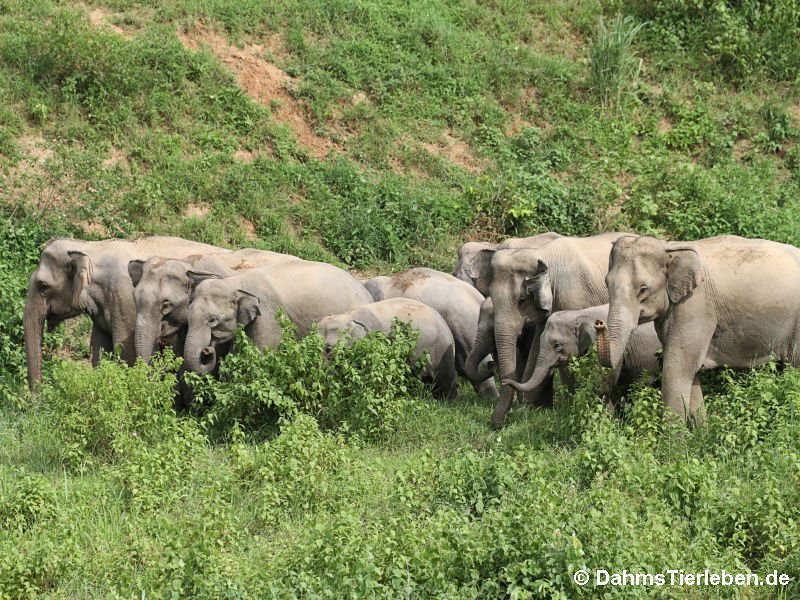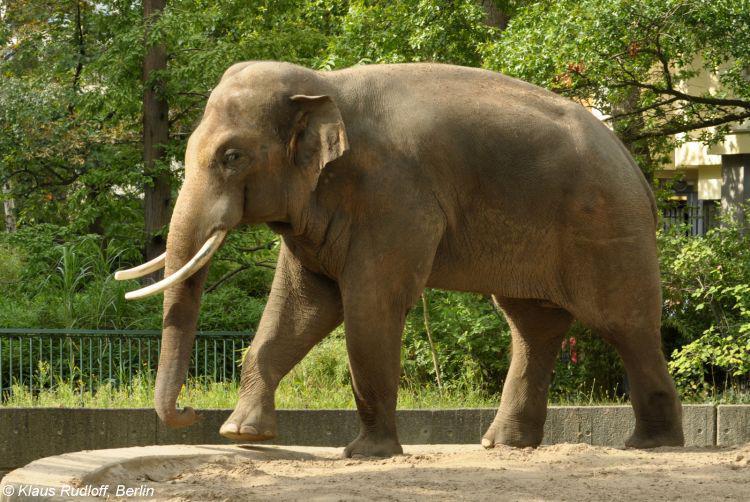The first image is the image on the left, the second image is the image on the right. Examine the images to the left and right. Is the description "At least one image contains one elephant, which has large tusks." accurate? Answer yes or no. Yes. The first image is the image on the left, the second image is the image on the right. For the images shown, is this caption "There is exactly one animal in the image on the right." true? Answer yes or no. Yes. 